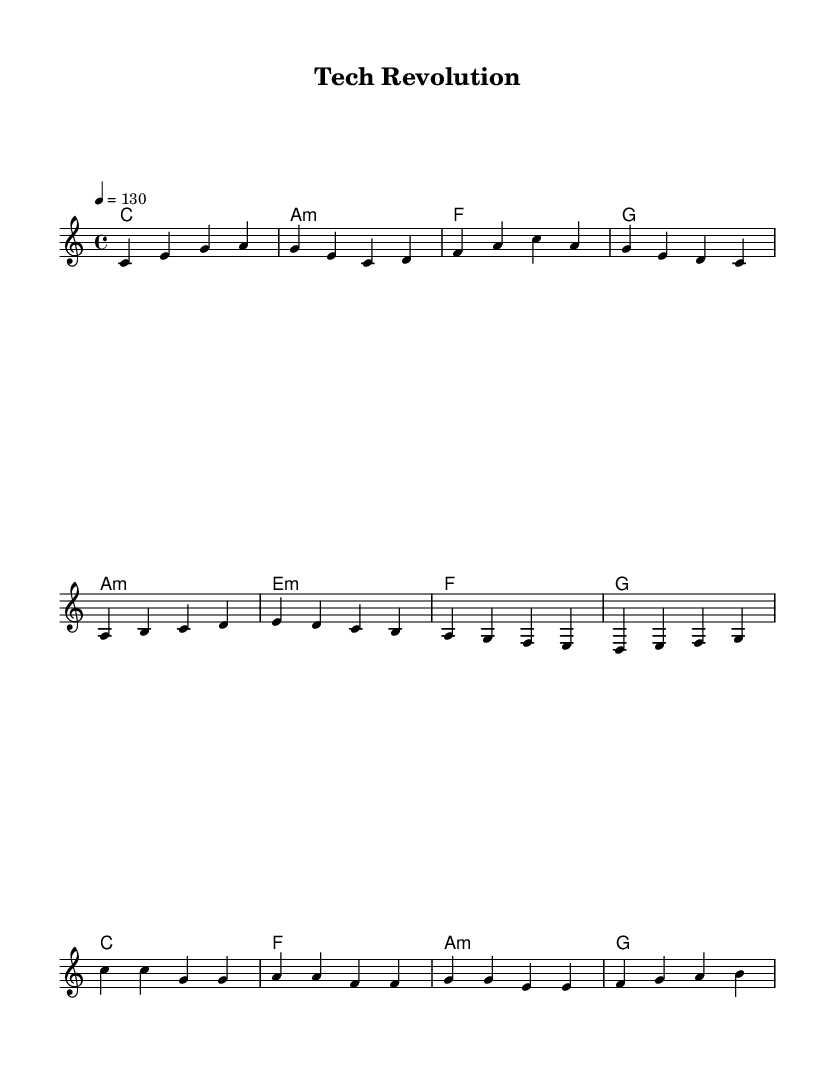What is the key signature of this music? The key signature is C major, which has no sharps or flats.
Answer: C major What is the time signature of this music? The time signature is defined as 4/4, indicating four beats per measure.
Answer: 4/4 What is the tempo of the piece? The tempo is indicated to be 130 beats per minute, shown by the marking "4 = 130".
Answer: 130 How many measures are in the verse section? The verse contains four measures, which can be counted from the melody section.
Answer: 4 What is the chord for the chorus? The chords for the chorus are C major, F major, A minor, and G major, as written in the harmonies section.
Answer: C, F, A minor, G In which section does the melody ascend more frequently, verse or chorus? The melody shows more frequent ascending motion in the chorus with notes moving up from G to A and A to B.
Answer: Chorus Which chord type is repeated in the pre-chorus? The chord type repeated in the pre-chorus is E minor, as indicated by the measure with E:m.
Answer: E minor 